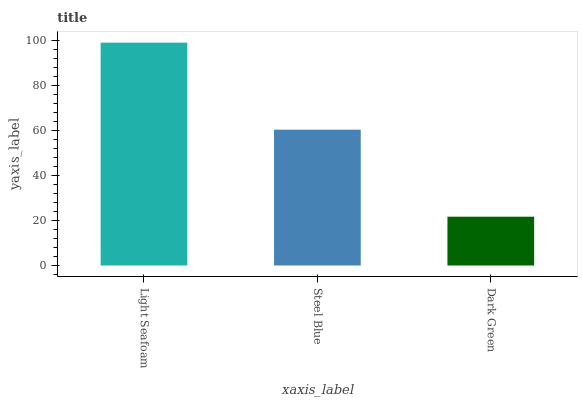Is Steel Blue the minimum?
Answer yes or no. No. Is Steel Blue the maximum?
Answer yes or no. No. Is Light Seafoam greater than Steel Blue?
Answer yes or no. Yes. Is Steel Blue less than Light Seafoam?
Answer yes or no. Yes. Is Steel Blue greater than Light Seafoam?
Answer yes or no. No. Is Light Seafoam less than Steel Blue?
Answer yes or no. No. Is Steel Blue the high median?
Answer yes or no. Yes. Is Steel Blue the low median?
Answer yes or no. Yes. Is Light Seafoam the high median?
Answer yes or no. No. Is Dark Green the low median?
Answer yes or no. No. 